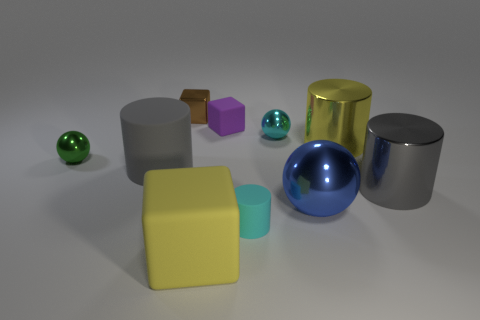Subtract all spheres. How many objects are left? 7 Subtract 0 purple cylinders. How many objects are left? 10 Subtract all cyan cylinders. Subtract all tiny brown blocks. How many objects are left? 8 Add 9 large yellow cubes. How many large yellow cubes are left? 10 Add 1 big yellow shiny cylinders. How many big yellow shiny cylinders exist? 2 